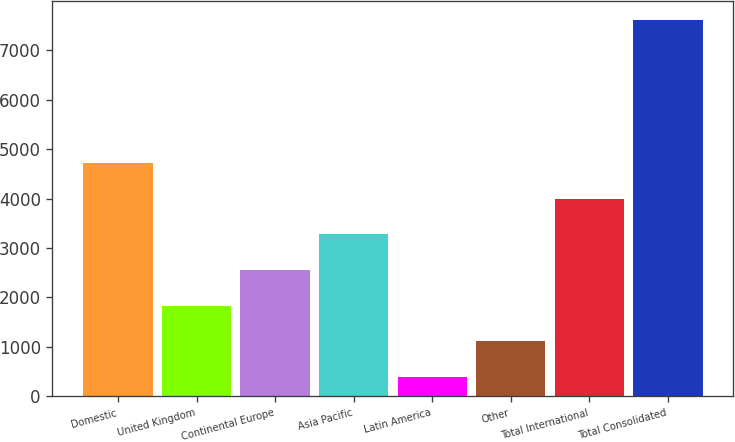<chart> <loc_0><loc_0><loc_500><loc_500><bar_chart><fcel>Domestic<fcel>United Kingdom<fcel>Continental Europe<fcel>Asia Pacific<fcel>Latin America<fcel>Other<fcel>Total International<fcel>Total Consolidated<nl><fcel>4721.68<fcel>1829.56<fcel>2552.59<fcel>3275.62<fcel>383.5<fcel>1106.53<fcel>3998.65<fcel>7613.8<nl></chart> 